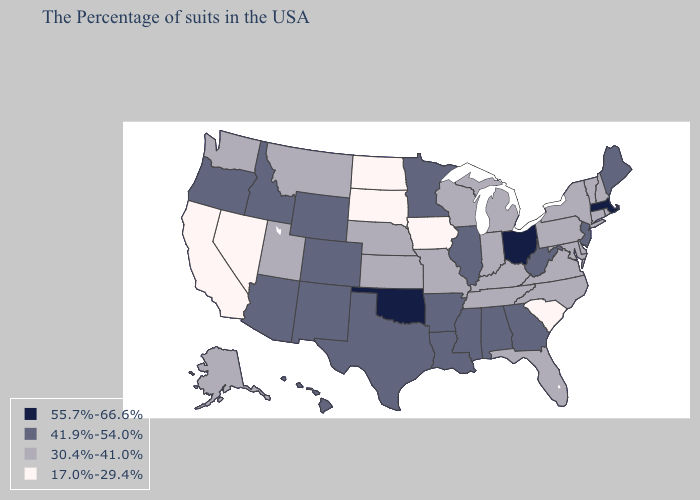Does Arizona have the lowest value in the USA?
Answer briefly. No. What is the lowest value in the South?
Be succinct. 17.0%-29.4%. What is the value of Washington?
Quick response, please. 30.4%-41.0%. Which states have the lowest value in the MidWest?
Keep it brief. Iowa, South Dakota, North Dakota. Which states have the lowest value in the Northeast?
Answer briefly. Rhode Island, New Hampshire, Vermont, Connecticut, New York, Pennsylvania. Among the states that border Indiana , which have the lowest value?
Answer briefly. Michigan, Kentucky. Does Wisconsin have the highest value in the MidWest?
Answer briefly. No. What is the value of Rhode Island?
Be succinct. 30.4%-41.0%. Which states hav the highest value in the MidWest?
Write a very short answer. Ohio. Does Alaska have the lowest value in the West?
Write a very short answer. No. What is the highest value in the USA?
Give a very brief answer. 55.7%-66.6%. What is the value of Virginia?
Quick response, please. 30.4%-41.0%. Does New Mexico have the lowest value in the West?
Be succinct. No. How many symbols are there in the legend?
Short answer required. 4. Does the first symbol in the legend represent the smallest category?
Short answer required. No. 